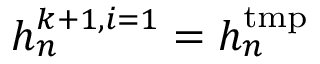<formula> <loc_0><loc_0><loc_500><loc_500>h _ { n } ^ { k + 1 , i = 1 } = h _ { n } ^ { t m p }</formula> 